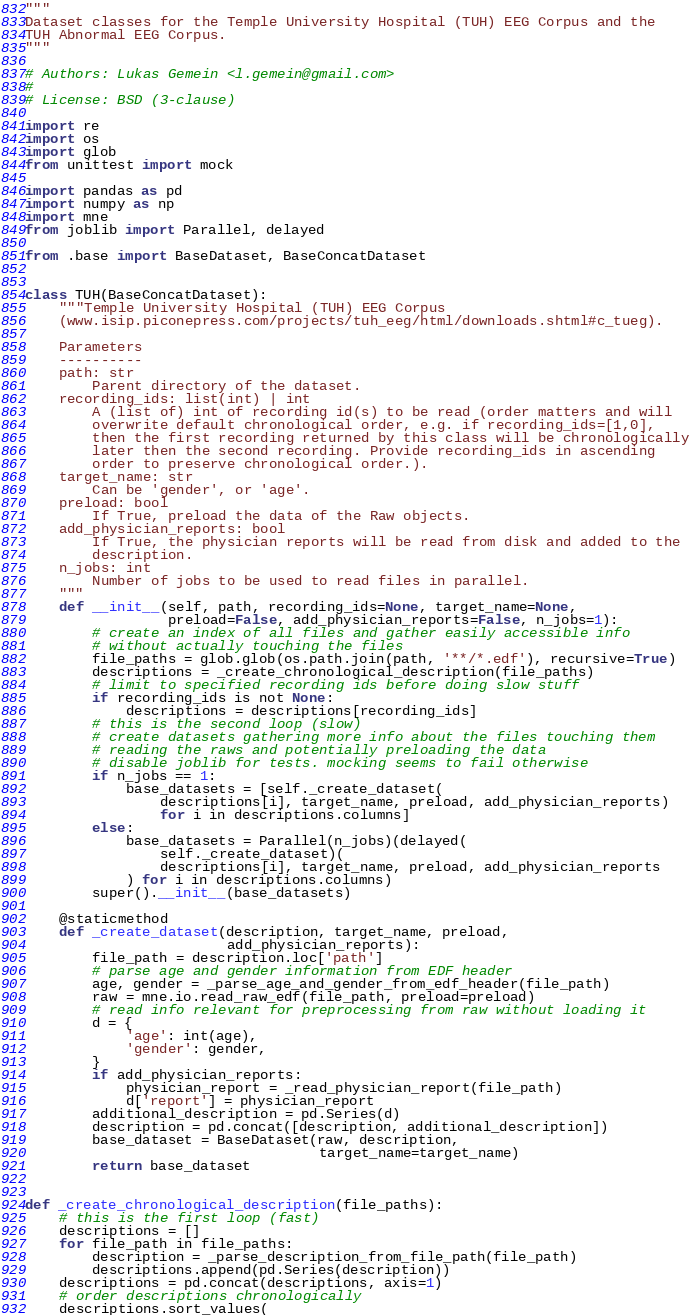Convert code to text. <code><loc_0><loc_0><loc_500><loc_500><_Python_>"""
Dataset classes for the Temple University Hospital (TUH) EEG Corpus and the
TUH Abnormal EEG Corpus.
"""

# Authors: Lukas Gemein <l.gemein@gmail.com>
#
# License: BSD (3-clause)

import re
import os
import glob
from unittest import mock

import pandas as pd
import numpy as np
import mne
from joblib import Parallel, delayed

from .base import BaseDataset, BaseConcatDataset


class TUH(BaseConcatDataset):
    """Temple University Hospital (TUH) EEG Corpus
    (www.isip.piconepress.com/projects/tuh_eeg/html/downloads.shtml#c_tueg).

    Parameters
    ----------
    path: str
        Parent directory of the dataset.
    recording_ids: list(int) | int
        A (list of) int of recording id(s) to be read (order matters and will
        overwrite default chronological order, e.g. if recording_ids=[1,0],
        then the first recording returned by this class will be chronologically
        later then the second recording. Provide recording_ids in ascending
        order to preserve chronological order.).
    target_name: str
        Can be 'gender', or 'age'.
    preload: bool
        If True, preload the data of the Raw objects.
    add_physician_reports: bool
        If True, the physician reports will be read from disk and added to the
        description.
    n_jobs: int
        Number of jobs to be used to read files in parallel.
    """
    def __init__(self, path, recording_ids=None, target_name=None,
                 preload=False, add_physician_reports=False, n_jobs=1):
        # create an index of all files and gather easily accessible info
        # without actually touching the files
        file_paths = glob.glob(os.path.join(path, '**/*.edf'), recursive=True)
        descriptions = _create_chronological_description(file_paths)
        # limit to specified recording ids before doing slow stuff
        if recording_ids is not None:
            descriptions = descriptions[recording_ids]
        # this is the second loop (slow)
        # create datasets gathering more info about the files touching them
        # reading the raws and potentially preloading the data
        # disable joblib for tests. mocking seems to fail otherwise
        if n_jobs == 1:
            base_datasets = [self._create_dataset(
                descriptions[i], target_name, preload, add_physician_reports)
                for i in descriptions.columns]
        else:
            base_datasets = Parallel(n_jobs)(delayed(
                self._create_dataset)(
                descriptions[i], target_name, preload, add_physician_reports
            ) for i in descriptions.columns)
        super().__init__(base_datasets)

    @staticmethod
    def _create_dataset(description, target_name, preload,
                        add_physician_reports):
        file_path = description.loc['path']
        # parse age and gender information from EDF header
        age, gender = _parse_age_and_gender_from_edf_header(file_path)
        raw = mne.io.read_raw_edf(file_path, preload=preload)
        # read info relevant for preprocessing from raw without loading it
        d = {
            'age': int(age),
            'gender': gender,
        }
        if add_physician_reports:
            physician_report = _read_physician_report(file_path)
            d['report'] = physician_report
        additional_description = pd.Series(d)
        description = pd.concat([description, additional_description])
        base_dataset = BaseDataset(raw, description,
                                   target_name=target_name)
        return base_dataset


def _create_chronological_description(file_paths):
    # this is the first loop (fast)
    descriptions = []
    for file_path in file_paths:
        description = _parse_description_from_file_path(file_path)
        descriptions.append(pd.Series(description))
    descriptions = pd.concat(descriptions, axis=1)
    # order descriptions chronologically
    descriptions.sort_values(</code> 